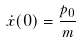Convert formula to latex. <formula><loc_0><loc_0><loc_500><loc_500>\dot { x } ( 0 ) = \frac { p _ { 0 } } { m }</formula> 